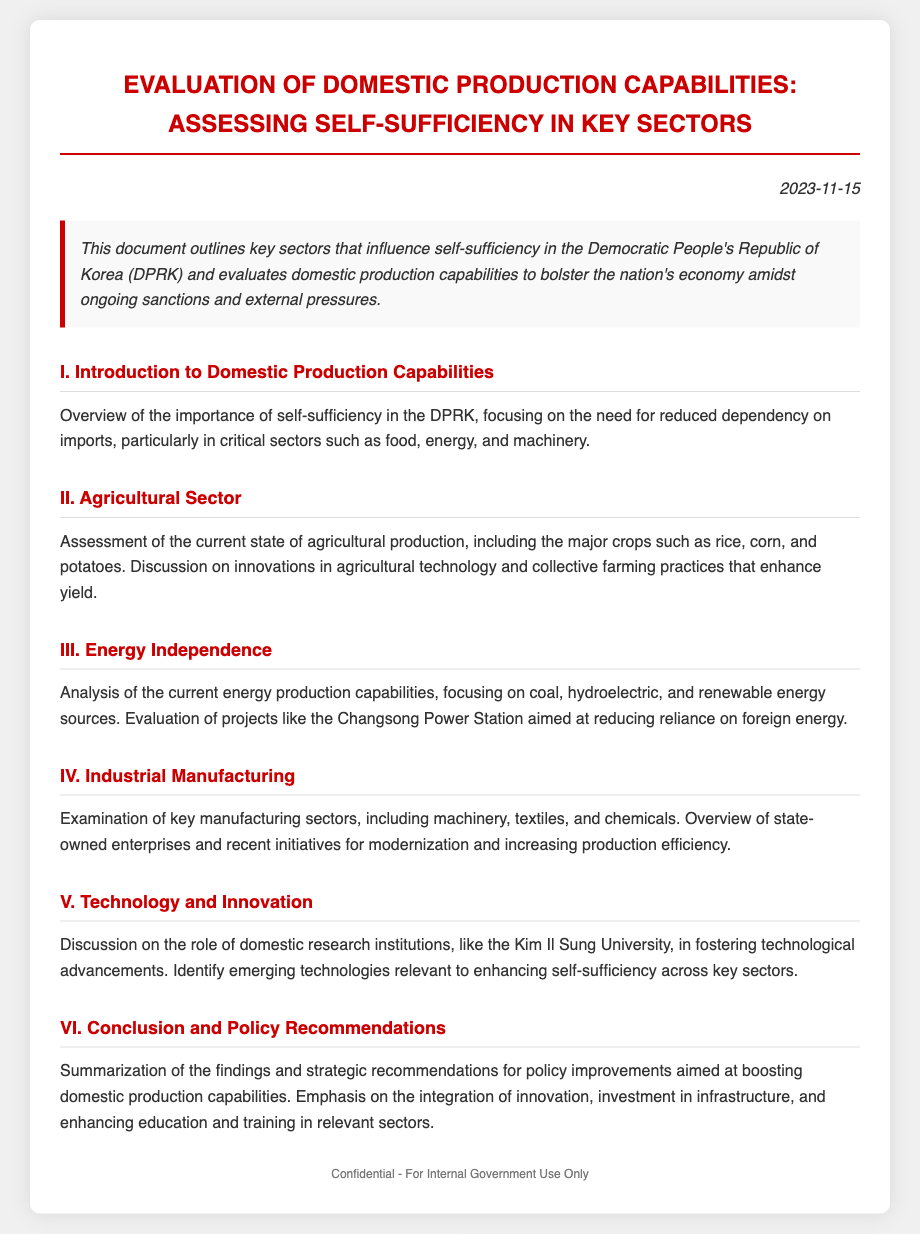What is the title of the document? The title of the document outlines the main focus of the evaluation regarding domestic production capabilities.
Answer: Evaluation of Domestic Production Capabilities: Assessing Self-Sufficiency in Key Sectors What date is the document dated? The date appears prominently in the document's header, indicating when it was created.
Answer: 2023-11-15 What key sectors are focused on regarding self-sufficiency? The document specifies critical areas within the context of self-sufficiency in the DPRK.
Answer: Food, energy, machinery Which agricultural crops are mentioned? The document lists major crops in the assessment of the agricultural sector; these are crucial for food security.
Answer: Rice, corn, potatoes What energy sources are analyzed in the document? The document evaluates various energy production capabilities and sustainable practices.
Answer: Coal, hydroelectric, renewable energy What institution is discussed in the context of technology and innovation? The role of a specific research institution in enhancing domestic technology solutions is highlighted.
Answer: Kim Il Sung University What is a key recommendation in the conclusion? The document summarizes strategic pathways based on findings to enhance self-sufficiency.
Answer: Investment in infrastructure Which power station is mentioned as a project for energy independence? The document provides an example of energy infrastructure aimed at reducing reliance on foreign sources.
Answer: Changsong Power Station 